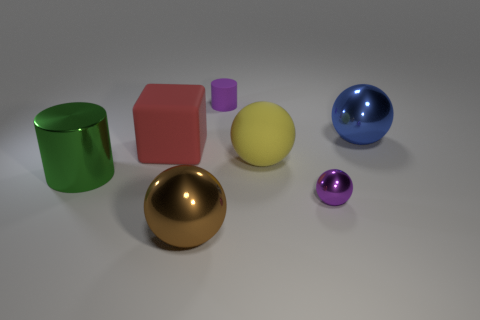Which objects in the picture look like they have a reflective surface? The objects with reflective surfaces in the image are the green cylinder, the blue sphere, and the golden sphere. Their surfaces appear smooth and mirror-like, which makes them reflect the environment. 